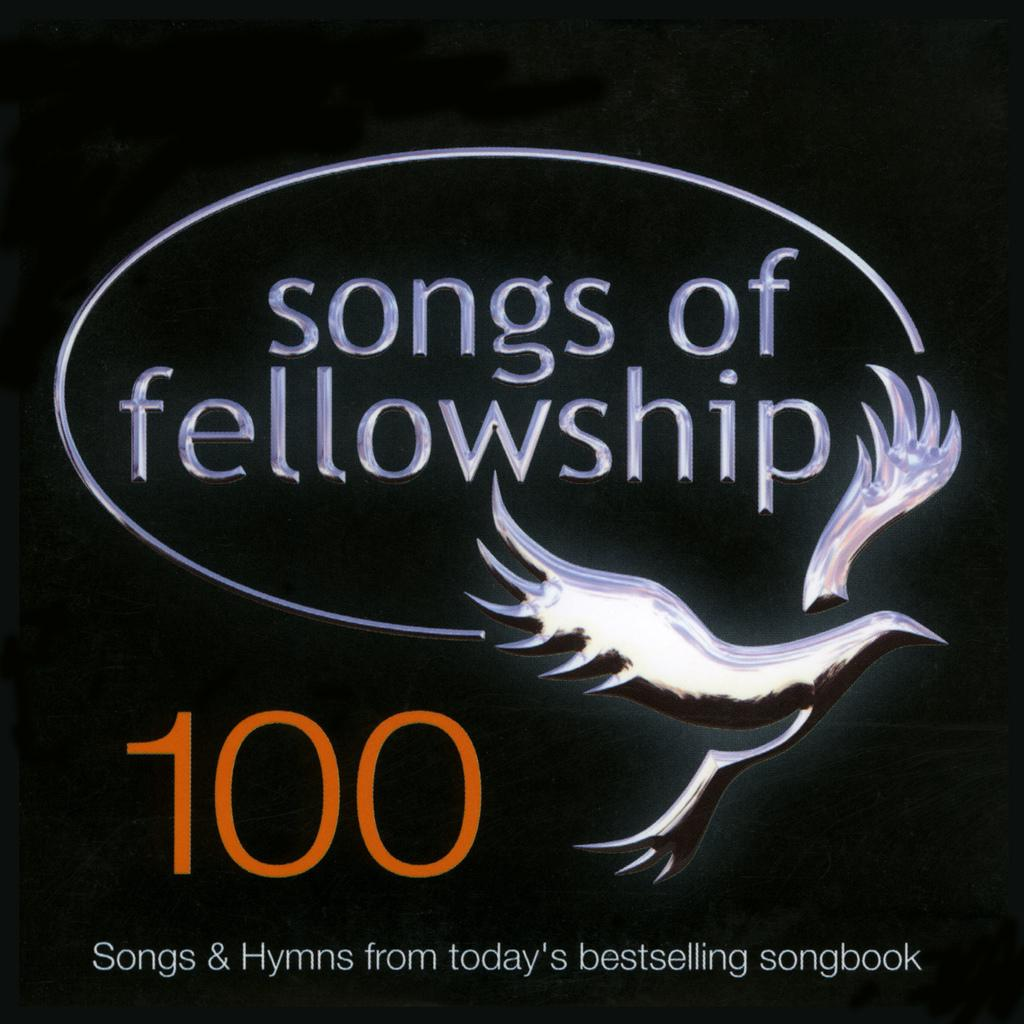What is written on the picture? The phrase "songs of fellowship" is written on the picture. Is there any other text on the picture? Yes, there is additional text written below the phrase. How many carts are visible in the picture? There are no carts visible in the picture; the image only contains text. What color are the toes of the person in the picture? There is no person or toes present in the picture; it only contains text. 